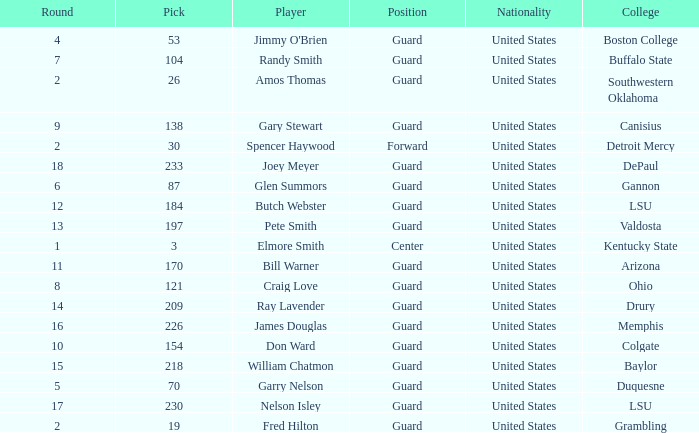What educational institution has a circular shape exceeding 9, including butch webster? LSU. 